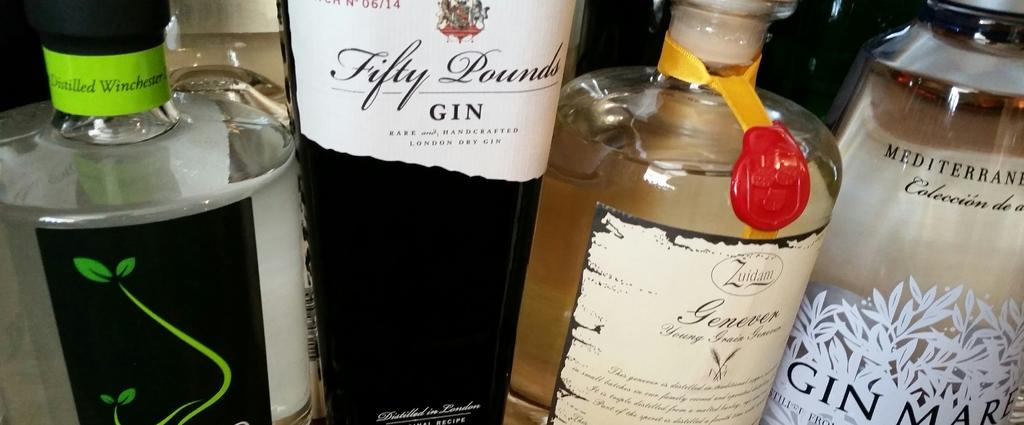<image>
Share a concise interpretation of the image provided. Four different bottles of gin are available to drink. 